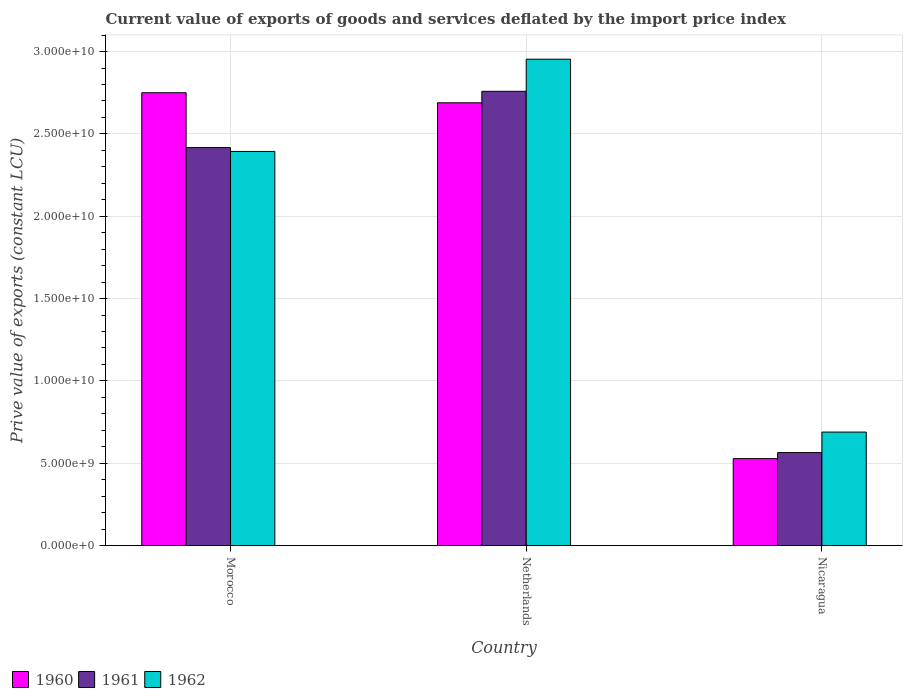How many different coloured bars are there?
Offer a very short reply. 3. Are the number of bars per tick equal to the number of legend labels?
Keep it short and to the point. Yes. Are the number of bars on each tick of the X-axis equal?
Provide a short and direct response. Yes. How many bars are there on the 1st tick from the left?
Your answer should be very brief. 3. What is the label of the 2nd group of bars from the left?
Ensure brevity in your answer.  Netherlands. In how many cases, is the number of bars for a given country not equal to the number of legend labels?
Provide a succinct answer. 0. What is the prive value of exports in 1962 in Morocco?
Ensure brevity in your answer.  2.39e+1. Across all countries, what is the maximum prive value of exports in 1962?
Make the answer very short. 2.95e+1. Across all countries, what is the minimum prive value of exports in 1961?
Provide a succinct answer. 5.65e+09. In which country was the prive value of exports in 1961 minimum?
Offer a terse response. Nicaragua. What is the total prive value of exports in 1961 in the graph?
Offer a terse response. 5.74e+1. What is the difference between the prive value of exports in 1961 in Netherlands and that in Nicaragua?
Make the answer very short. 2.19e+1. What is the difference between the prive value of exports in 1962 in Netherlands and the prive value of exports in 1960 in Nicaragua?
Keep it short and to the point. 2.43e+1. What is the average prive value of exports in 1961 per country?
Offer a very short reply. 1.91e+1. What is the difference between the prive value of exports of/in 1960 and prive value of exports of/in 1961 in Nicaragua?
Your answer should be compact. -3.67e+08. What is the ratio of the prive value of exports in 1962 in Morocco to that in Netherlands?
Your answer should be compact. 0.81. What is the difference between the highest and the second highest prive value of exports in 1962?
Keep it short and to the point. 5.60e+09. What is the difference between the highest and the lowest prive value of exports in 1962?
Your answer should be compact. 2.26e+1. In how many countries, is the prive value of exports in 1962 greater than the average prive value of exports in 1962 taken over all countries?
Offer a very short reply. 2. Is the sum of the prive value of exports in 1962 in Morocco and Netherlands greater than the maximum prive value of exports in 1960 across all countries?
Provide a succinct answer. Yes. What does the 2nd bar from the left in Morocco represents?
Your answer should be compact. 1961. Is it the case that in every country, the sum of the prive value of exports in 1962 and prive value of exports in 1960 is greater than the prive value of exports in 1961?
Ensure brevity in your answer.  Yes. How many bars are there?
Ensure brevity in your answer.  9. Are all the bars in the graph horizontal?
Your response must be concise. No. How many countries are there in the graph?
Give a very brief answer. 3. What is the difference between two consecutive major ticks on the Y-axis?
Provide a short and direct response. 5.00e+09. Does the graph contain any zero values?
Your answer should be very brief. No. Does the graph contain grids?
Your answer should be very brief. Yes. Where does the legend appear in the graph?
Ensure brevity in your answer.  Bottom left. How are the legend labels stacked?
Offer a very short reply. Horizontal. What is the title of the graph?
Provide a short and direct response. Current value of exports of goods and services deflated by the import price index. What is the label or title of the X-axis?
Your answer should be compact. Country. What is the label or title of the Y-axis?
Offer a terse response. Prive value of exports (constant LCU). What is the Prive value of exports (constant LCU) in 1960 in Morocco?
Offer a very short reply. 2.75e+1. What is the Prive value of exports (constant LCU) in 1961 in Morocco?
Keep it short and to the point. 2.42e+1. What is the Prive value of exports (constant LCU) in 1962 in Morocco?
Offer a very short reply. 2.39e+1. What is the Prive value of exports (constant LCU) in 1960 in Netherlands?
Offer a terse response. 2.69e+1. What is the Prive value of exports (constant LCU) of 1961 in Netherlands?
Offer a terse response. 2.76e+1. What is the Prive value of exports (constant LCU) of 1962 in Netherlands?
Give a very brief answer. 2.95e+1. What is the Prive value of exports (constant LCU) of 1960 in Nicaragua?
Give a very brief answer. 5.28e+09. What is the Prive value of exports (constant LCU) of 1961 in Nicaragua?
Your answer should be very brief. 5.65e+09. What is the Prive value of exports (constant LCU) of 1962 in Nicaragua?
Provide a short and direct response. 6.89e+09. Across all countries, what is the maximum Prive value of exports (constant LCU) of 1960?
Ensure brevity in your answer.  2.75e+1. Across all countries, what is the maximum Prive value of exports (constant LCU) in 1961?
Provide a short and direct response. 2.76e+1. Across all countries, what is the maximum Prive value of exports (constant LCU) of 1962?
Keep it short and to the point. 2.95e+1. Across all countries, what is the minimum Prive value of exports (constant LCU) of 1960?
Give a very brief answer. 5.28e+09. Across all countries, what is the minimum Prive value of exports (constant LCU) in 1961?
Offer a very short reply. 5.65e+09. Across all countries, what is the minimum Prive value of exports (constant LCU) of 1962?
Make the answer very short. 6.89e+09. What is the total Prive value of exports (constant LCU) in 1960 in the graph?
Provide a succinct answer. 5.97e+1. What is the total Prive value of exports (constant LCU) of 1961 in the graph?
Your response must be concise. 5.74e+1. What is the total Prive value of exports (constant LCU) of 1962 in the graph?
Your answer should be very brief. 6.04e+1. What is the difference between the Prive value of exports (constant LCU) in 1960 in Morocco and that in Netherlands?
Offer a very short reply. 6.10e+08. What is the difference between the Prive value of exports (constant LCU) of 1961 in Morocco and that in Netherlands?
Your response must be concise. -3.42e+09. What is the difference between the Prive value of exports (constant LCU) in 1962 in Morocco and that in Netherlands?
Your answer should be compact. -5.60e+09. What is the difference between the Prive value of exports (constant LCU) of 1960 in Morocco and that in Nicaragua?
Offer a terse response. 2.22e+1. What is the difference between the Prive value of exports (constant LCU) in 1961 in Morocco and that in Nicaragua?
Keep it short and to the point. 1.85e+1. What is the difference between the Prive value of exports (constant LCU) of 1962 in Morocco and that in Nicaragua?
Give a very brief answer. 1.70e+1. What is the difference between the Prive value of exports (constant LCU) in 1960 in Netherlands and that in Nicaragua?
Your answer should be very brief. 2.16e+1. What is the difference between the Prive value of exports (constant LCU) in 1961 in Netherlands and that in Nicaragua?
Make the answer very short. 2.19e+1. What is the difference between the Prive value of exports (constant LCU) in 1962 in Netherlands and that in Nicaragua?
Provide a succinct answer. 2.26e+1. What is the difference between the Prive value of exports (constant LCU) in 1960 in Morocco and the Prive value of exports (constant LCU) in 1961 in Netherlands?
Your answer should be very brief. -8.70e+07. What is the difference between the Prive value of exports (constant LCU) in 1960 in Morocco and the Prive value of exports (constant LCU) in 1962 in Netherlands?
Provide a succinct answer. -2.04e+09. What is the difference between the Prive value of exports (constant LCU) of 1961 in Morocco and the Prive value of exports (constant LCU) of 1962 in Netherlands?
Offer a terse response. -5.37e+09. What is the difference between the Prive value of exports (constant LCU) in 1960 in Morocco and the Prive value of exports (constant LCU) in 1961 in Nicaragua?
Ensure brevity in your answer.  2.19e+1. What is the difference between the Prive value of exports (constant LCU) of 1960 in Morocco and the Prive value of exports (constant LCU) of 1962 in Nicaragua?
Your answer should be compact. 2.06e+1. What is the difference between the Prive value of exports (constant LCU) of 1961 in Morocco and the Prive value of exports (constant LCU) of 1962 in Nicaragua?
Provide a short and direct response. 1.73e+1. What is the difference between the Prive value of exports (constant LCU) in 1960 in Netherlands and the Prive value of exports (constant LCU) in 1961 in Nicaragua?
Make the answer very short. 2.12e+1. What is the difference between the Prive value of exports (constant LCU) of 1960 in Netherlands and the Prive value of exports (constant LCU) of 1962 in Nicaragua?
Keep it short and to the point. 2.00e+1. What is the difference between the Prive value of exports (constant LCU) in 1961 in Netherlands and the Prive value of exports (constant LCU) in 1962 in Nicaragua?
Provide a succinct answer. 2.07e+1. What is the average Prive value of exports (constant LCU) in 1960 per country?
Offer a terse response. 1.99e+1. What is the average Prive value of exports (constant LCU) of 1961 per country?
Offer a very short reply. 1.91e+1. What is the average Prive value of exports (constant LCU) in 1962 per country?
Provide a succinct answer. 2.01e+1. What is the difference between the Prive value of exports (constant LCU) of 1960 and Prive value of exports (constant LCU) of 1961 in Morocco?
Your answer should be very brief. 3.33e+09. What is the difference between the Prive value of exports (constant LCU) of 1960 and Prive value of exports (constant LCU) of 1962 in Morocco?
Provide a succinct answer. 3.56e+09. What is the difference between the Prive value of exports (constant LCU) of 1961 and Prive value of exports (constant LCU) of 1962 in Morocco?
Offer a terse response. 2.33e+08. What is the difference between the Prive value of exports (constant LCU) of 1960 and Prive value of exports (constant LCU) of 1961 in Netherlands?
Offer a very short reply. -6.97e+08. What is the difference between the Prive value of exports (constant LCU) in 1960 and Prive value of exports (constant LCU) in 1962 in Netherlands?
Make the answer very short. -2.65e+09. What is the difference between the Prive value of exports (constant LCU) in 1961 and Prive value of exports (constant LCU) in 1962 in Netherlands?
Ensure brevity in your answer.  -1.95e+09. What is the difference between the Prive value of exports (constant LCU) in 1960 and Prive value of exports (constant LCU) in 1961 in Nicaragua?
Offer a terse response. -3.67e+08. What is the difference between the Prive value of exports (constant LCU) of 1960 and Prive value of exports (constant LCU) of 1962 in Nicaragua?
Your answer should be compact. -1.61e+09. What is the difference between the Prive value of exports (constant LCU) of 1961 and Prive value of exports (constant LCU) of 1962 in Nicaragua?
Your response must be concise. -1.25e+09. What is the ratio of the Prive value of exports (constant LCU) in 1960 in Morocco to that in Netherlands?
Ensure brevity in your answer.  1.02. What is the ratio of the Prive value of exports (constant LCU) of 1961 in Morocco to that in Netherlands?
Offer a terse response. 0.88. What is the ratio of the Prive value of exports (constant LCU) of 1962 in Morocco to that in Netherlands?
Ensure brevity in your answer.  0.81. What is the ratio of the Prive value of exports (constant LCU) in 1960 in Morocco to that in Nicaragua?
Provide a succinct answer. 5.21. What is the ratio of the Prive value of exports (constant LCU) of 1961 in Morocco to that in Nicaragua?
Your answer should be very brief. 4.28. What is the ratio of the Prive value of exports (constant LCU) of 1962 in Morocco to that in Nicaragua?
Provide a short and direct response. 3.47. What is the ratio of the Prive value of exports (constant LCU) in 1960 in Netherlands to that in Nicaragua?
Provide a succinct answer. 5.09. What is the ratio of the Prive value of exports (constant LCU) of 1961 in Netherlands to that in Nicaragua?
Your answer should be compact. 4.89. What is the ratio of the Prive value of exports (constant LCU) in 1962 in Netherlands to that in Nicaragua?
Keep it short and to the point. 4.29. What is the difference between the highest and the second highest Prive value of exports (constant LCU) of 1960?
Your answer should be compact. 6.10e+08. What is the difference between the highest and the second highest Prive value of exports (constant LCU) in 1961?
Offer a very short reply. 3.42e+09. What is the difference between the highest and the second highest Prive value of exports (constant LCU) in 1962?
Keep it short and to the point. 5.60e+09. What is the difference between the highest and the lowest Prive value of exports (constant LCU) of 1960?
Give a very brief answer. 2.22e+1. What is the difference between the highest and the lowest Prive value of exports (constant LCU) of 1961?
Provide a succinct answer. 2.19e+1. What is the difference between the highest and the lowest Prive value of exports (constant LCU) of 1962?
Offer a terse response. 2.26e+1. 